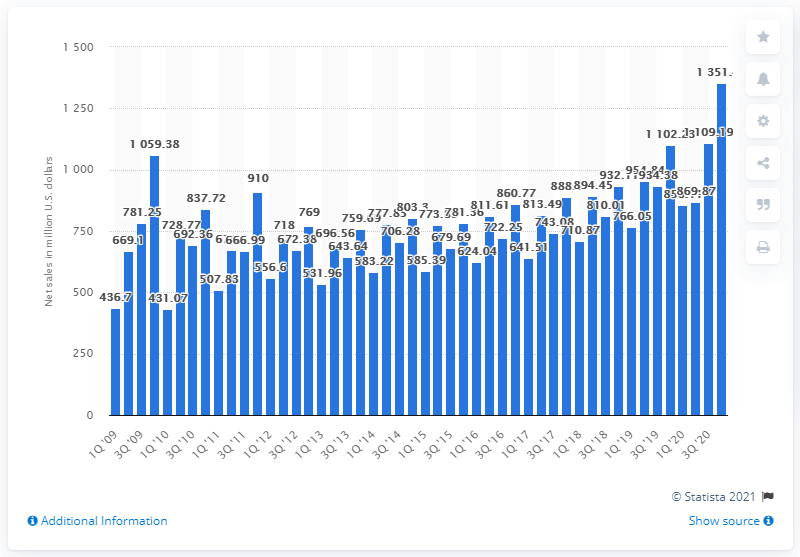Outline some significant characteristics in this image. Garmin reported a revenue of 1,351.41 in the fourth quarter of 2020. 